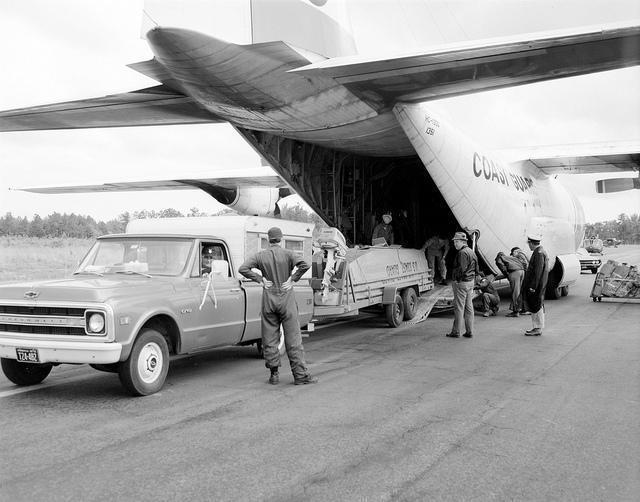Does the image validate the caption "The truck is under the airplane."?
Answer yes or no. Yes. Is "The truck is at the back of the airplane." an appropriate description for the image?
Answer yes or no. Yes. 